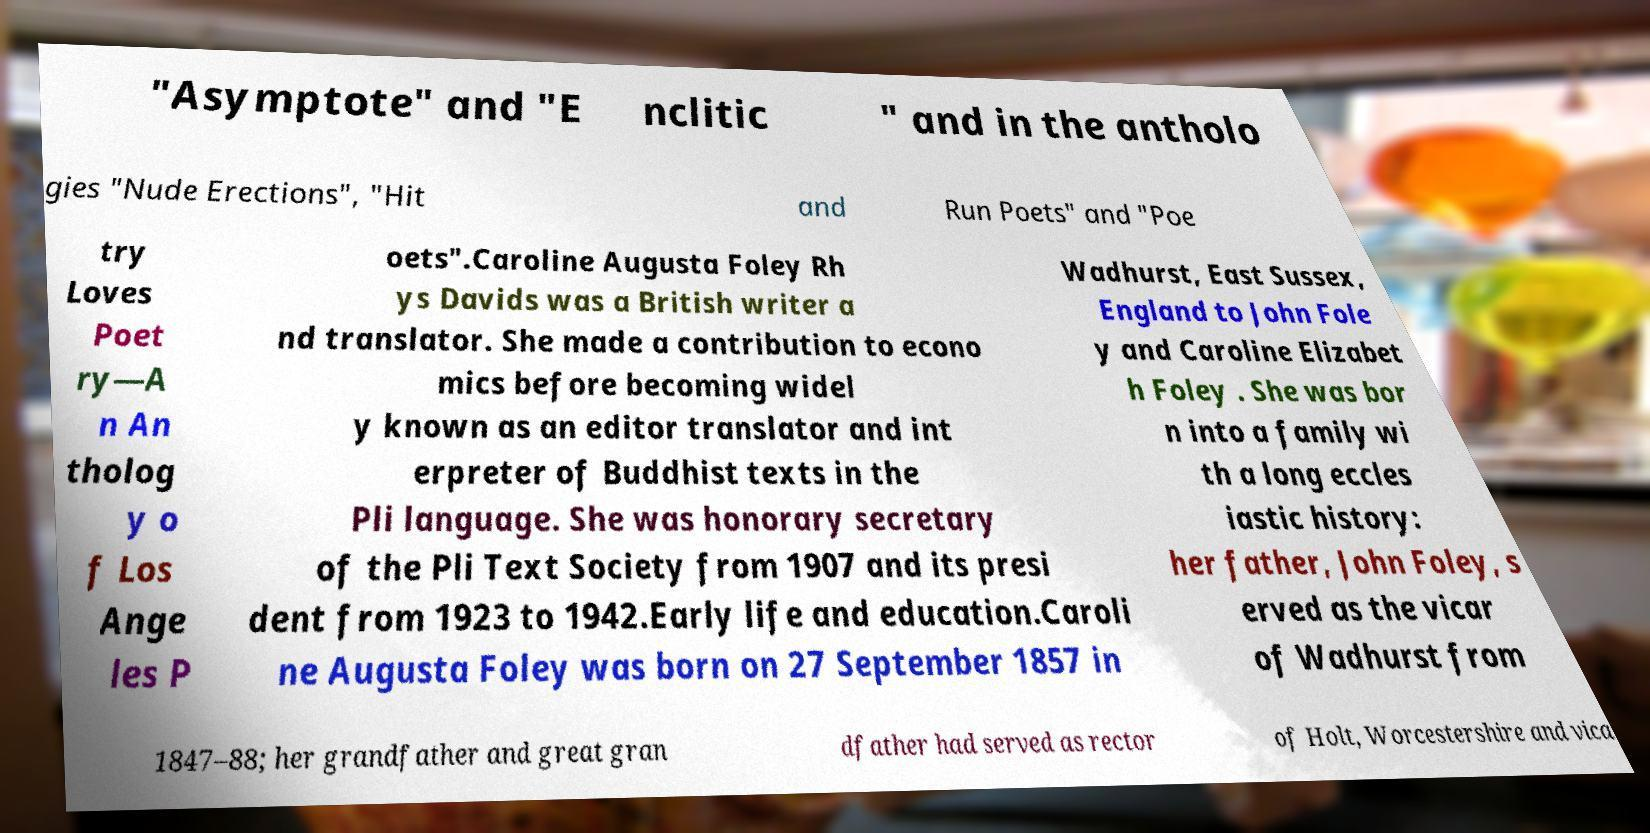Can you accurately transcribe the text from the provided image for me? "Asymptote" and "E nclitic " and in the antholo gies "Nude Erections", "Hit and Run Poets" and "Poe try Loves Poet ry—A n An tholog y o f Los Ange les P oets".Caroline Augusta Foley Rh ys Davids was a British writer a nd translator. She made a contribution to econo mics before becoming widel y known as an editor translator and int erpreter of Buddhist texts in the Pli language. She was honorary secretary of the Pli Text Society from 1907 and its presi dent from 1923 to 1942.Early life and education.Caroli ne Augusta Foley was born on 27 September 1857 in Wadhurst, East Sussex, England to John Fole y and Caroline Elizabet h Foley . She was bor n into a family wi th a long eccles iastic history: her father, John Foley, s erved as the vicar of Wadhurst from 1847–88; her grandfather and great gran dfather had served as rector of Holt, Worcestershire and vica 